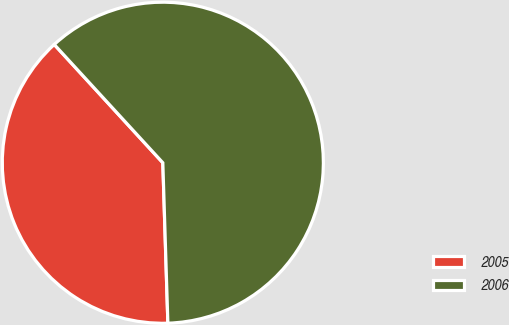Convert chart to OTSL. <chart><loc_0><loc_0><loc_500><loc_500><pie_chart><fcel>2005<fcel>2006<nl><fcel>38.68%<fcel>61.32%<nl></chart> 